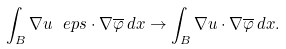<formula> <loc_0><loc_0><loc_500><loc_500>\int _ { B } \nabla u \ e p s \cdot \nabla \overline { \varphi } \, d x \to \int _ { B } \nabla u \cdot \nabla \overline { \varphi } \, d x .</formula> 